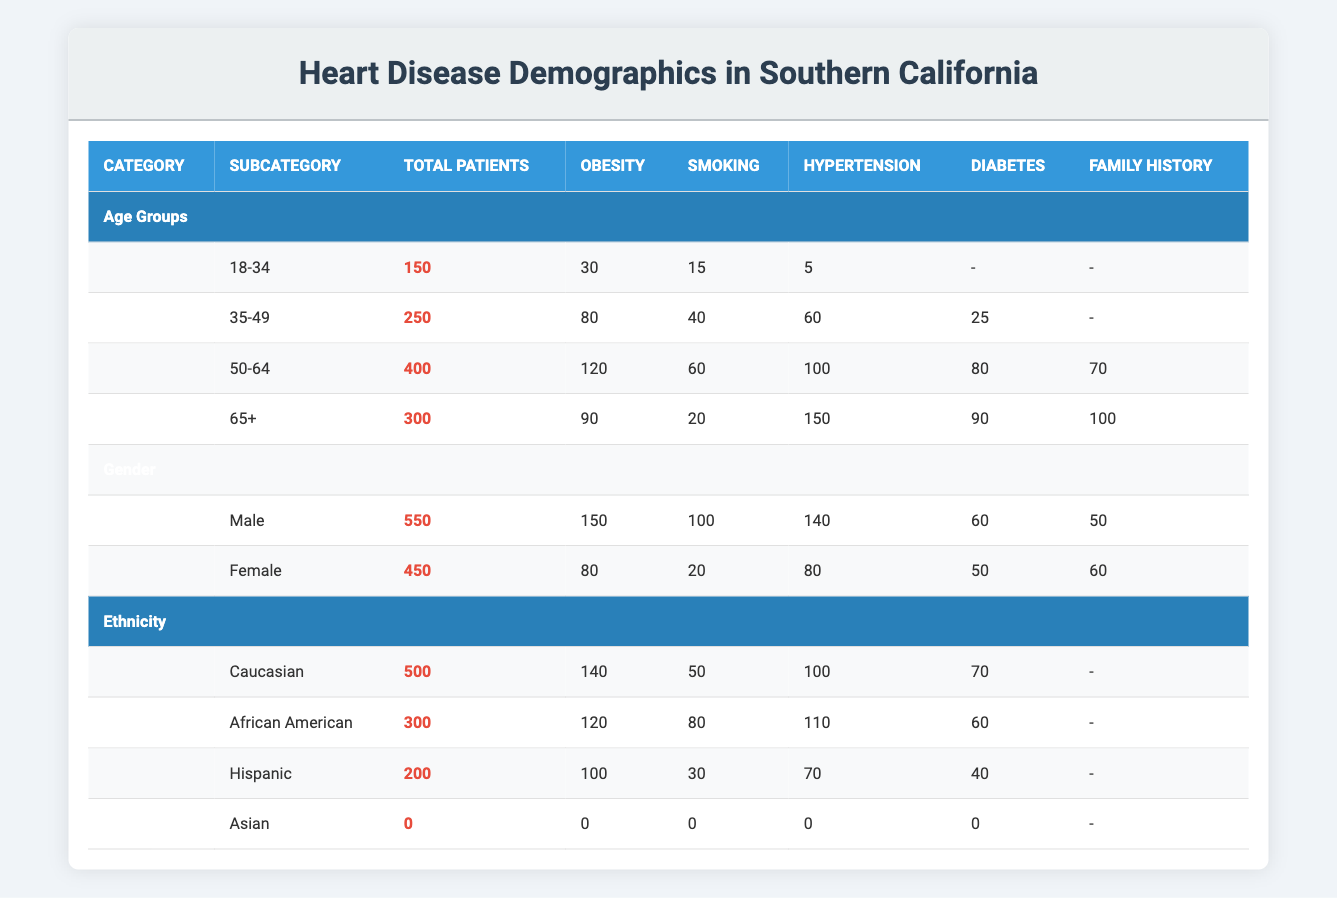What is the total number of patients in the 50-64 age group? The table shows a specific row for the 50-64 age group under Age Groups, where the Total Patients column states that there are 400 patients.
Answer: 400 How many total male patients have hypertension? The row for Male under the Gender category indicates there are 140 male patients with hypertension. The total for males is also provided, giving a clear insight into their risk factor.
Answer: 140 Which age group has the highest number of patients with diabetes? Looking at the Age Groups section, we examine each group for the number of reported diabetes cases. The 50-64 age group has 80 cases, while the 35-49 group has 25, the 18-34 group has none, and the 65+ group has 90. The highest number is in the 65+ age group with 90.
Answer: 65+ What is the average number of patients with obesity across all gender categories? The total patients with obesity for Male is 150, and for Female is 80. Adding these gives 230. The total number of patients for both genders is 550 (male) + 450 (female) = 1000. Thus, the average number of patients with obesity is 230/1000 = 0.23 or 23%.
Answer: 23% Are there any Asian patients reported in this study? The table under the Ethnicity section shows that for Asians, the Total Patients are 0. This indicates that there are no recorded Asian patients in this demographic study.
Answer: No What is the combined total of patients aged 18-34 and 35-49? To find the combined total, we add the Total Patients of the 18-34 age group (150) with those in the 35-49 group (250). So 150 + 250 = 400.
Answer: 400 Is obesity a more common risk factor among males than females in this region? Reviewing the risk factors, Males have 150 patients with obesity while Females have 80. This indicates that obesity is indeed more common among males than females in this demographic.
Answer: Yes What is the total number of patients classified as Hispanic? The table shows under the Ethnicity section that there are 200 patients classified as Hispanic.
Answer: 200 What is the difference in the number of patients with a family history between the 50-64 age group and the 65+ age group? Under the Age Groups section, the 50-64 age group has 70 patients with a family history, while the 65+ age group has 100. The difference is 100 - 70 = 30.
Answer: 30 